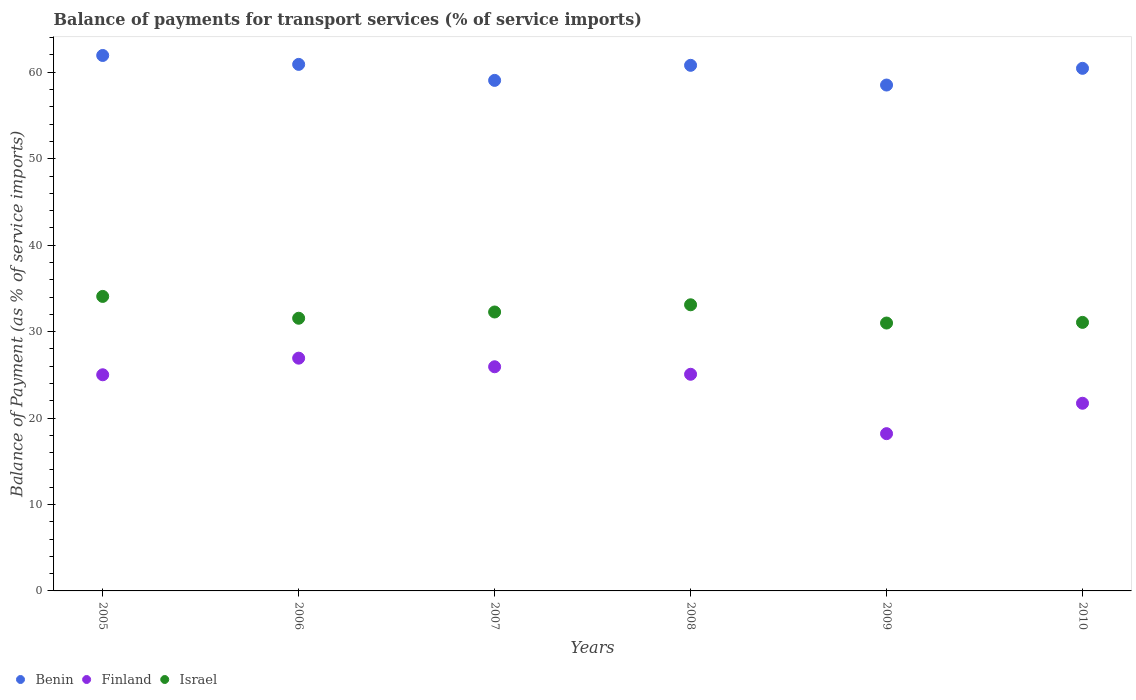How many different coloured dotlines are there?
Give a very brief answer. 3. Is the number of dotlines equal to the number of legend labels?
Your answer should be very brief. Yes. What is the balance of payments for transport services in Israel in 2005?
Provide a succinct answer. 34.07. Across all years, what is the maximum balance of payments for transport services in Benin?
Your answer should be compact. 61.94. Across all years, what is the minimum balance of payments for transport services in Finland?
Make the answer very short. 18.19. In which year was the balance of payments for transport services in Finland maximum?
Your response must be concise. 2006. What is the total balance of payments for transport services in Benin in the graph?
Your answer should be compact. 361.71. What is the difference between the balance of payments for transport services in Benin in 2008 and that in 2009?
Ensure brevity in your answer.  2.28. What is the difference between the balance of payments for transport services in Finland in 2009 and the balance of payments for transport services in Israel in 2007?
Ensure brevity in your answer.  -14.07. What is the average balance of payments for transport services in Benin per year?
Your answer should be compact. 60.28. In the year 2009, what is the difference between the balance of payments for transport services in Benin and balance of payments for transport services in Israel?
Provide a short and direct response. 27.53. What is the ratio of the balance of payments for transport services in Finland in 2005 to that in 2010?
Ensure brevity in your answer.  1.15. Is the balance of payments for transport services in Israel in 2005 less than that in 2010?
Your answer should be compact. No. What is the difference between the highest and the second highest balance of payments for transport services in Finland?
Provide a short and direct response. 1. What is the difference between the highest and the lowest balance of payments for transport services in Finland?
Provide a short and direct response. 8.73. Is the sum of the balance of payments for transport services in Finland in 2007 and 2010 greater than the maximum balance of payments for transport services in Israel across all years?
Ensure brevity in your answer.  Yes. Is it the case that in every year, the sum of the balance of payments for transport services in Israel and balance of payments for transport services in Finland  is greater than the balance of payments for transport services in Benin?
Offer a very short reply. No. Is the balance of payments for transport services in Benin strictly greater than the balance of payments for transport services in Finland over the years?
Your response must be concise. Yes. How many dotlines are there?
Offer a terse response. 3. What is the difference between two consecutive major ticks on the Y-axis?
Provide a short and direct response. 10. Does the graph contain any zero values?
Provide a short and direct response. No. How many legend labels are there?
Keep it short and to the point. 3. What is the title of the graph?
Provide a succinct answer. Balance of payments for transport services (% of service imports). What is the label or title of the Y-axis?
Provide a succinct answer. Balance of Payment (as % of service imports). What is the Balance of Payment (as % of service imports) in Benin in 2005?
Provide a succinct answer. 61.94. What is the Balance of Payment (as % of service imports) of Finland in 2005?
Ensure brevity in your answer.  25. What is the Balance of Payment (as % of service imports) of Israel in 2005?
Give a very brief answer. 34.07. What is the Balance of Payment (as % of service imports) in Benin in 2006?
Keep it short and to the point. 60.91. What is the Balance of Payment (as % of service imports) in Finland in 2006?
Provide a succinct answer. 26.93. What is the Balance of Payment (as % of service imports) of Israel in 2006?
Your answer should be very brief. 31.55. What is the Balance of Payment (as % of service imports) of Benin in 2007?
Provide a short and direct response. 59.06. What is the Balance of Payment (as % of service imports) in Finland in 2007?
Your answer should be compact. 25.93. What is the Balance of Payment (as % of service imports) in Israel in 2007?
Keep it short and to the point. 32.27. What is the Balance of Payment (as % of service imports) in Benin in 2008?
Provide a short and direct response. 60.81. What is the Balance of Payment (as % of service imports) in Finland in 2008?
Offer a terse response. 25.06. What is the Balance of Payment (as % of service imports) of Israel in 2008?
Give a very brief answer. 33.1. What is the Balance of Payment (as % of service imports) in Benin in 2009?
Offer a terse response. 58.52. What is the Balance of Payment (as % of service imports) of Finland in 2009?
Make the answer very short. 18.19. What is the Balance of Payment (as % of service imports) of Israel in 2009?
Your answer should be compact. 30.99. What is the Balance of Payment (as % of service imports) in Benin in 2010?
Provide a short and direct response. 60.46. What is the Balance of Payment (as % of service imports) of Finland in 2010?
Provide a short and direct response. 21.71. What is the Balance of Payment (as % of service imports) of Israel in 2010?
Make the answer very short. 31.07. Across all years, what is the maximum Balance of Payment (as % of service imports) of Benin?
Give a very brief answer. 61.94. Across all years, what is the maximum Balance of Payment (as % of service imports) of Finland?
Your response must be concise. 26.93. Across all years, what is the maximum Balance of Payment (as % of service imports) of Israel?
Give a very brief answer. 34.07. Across all years, what is the minimum Balance of Payment (as % of service imports) in Benin?
Your answer should be very brief. 58.52. Across all years, what is the minimum Balance of Payment (as % of service imports) in Finland?
Give a very brief answer. 18.19. Across all years, what is the minimum Balance of Payment (as % of service imports) in Israel?
Provide a succinct answer. 30.99. What is the total Balance of Payment (as % of service imports) in Benin in the graph?
Ensure brevity in your answer.  361.71. What is the total Balance of Payment (as % of service imports) of Finland in the graph?
Ensure brevity in your answer.  142.83. What is the total Balance of Payment (as % of service imports) in Israel in the graph?
Give a very brief answer. 193.04. What is the difference between the Balance of Payment (as % of service imports) of Benin in 2005 and that in 2006?
Offer a very short reply. 1.03. What is the difference between the Balance of Payment (as % of service imports) in Finland in 2005 and that in 2006?
Offer a terse response. -1.92. What is the difference between the Balance of Payment (as % of service imports) of Israel in 2005 and that in 2006?
Ensure brevity in your answer.  2.53. What is the difference between the Balance of Payment (as % of service imports) in Benin in 2005 and that in 2007?
Give a very brief answer. 2.88. What is the difference between the Balance of Payment (as % of service imports) in Finland in 2005 and that in 2007?
Your response must be concise. -0.93. What is the difference between the Balance of Payment (as % of service imports) in Israel in 2005 and that in 2007?
Your answer should be compact. 1.8. What is the difference between the Balance of Payment (as % of service imports) in Benin in 2005 and that in 2008?
Keep it short and to the point. 1.14. What is the difference between the Balance of Payment (as % of service imports) of Finland in 2005 and that in 2008?
Give a very brief answer. -0.06. What is the difference between the Balance of Payment (as % of service imports) of Israel in 2005 and that in 2008?
Ensure brevity in your answer.  0.97. What is the difference between the Balance of Payment (as % of service imports) in Benin in 2005 and that in 2009?
Your answer should be very brief. 3.42. What is the difference between the Balance of Payment (as % of service imports) in Finland in 2005 and that in 2009?
Provide a short and direct response. 6.81. What is the difference between the Balance of Payment (as % of service imports) in Israel in 2005 and that in 2009?
Keep it short and to the point. 3.08. What is the difference between the Balance of Payment (as % of service imports) of Benin in 2005 and that in 2010?
Provide a succinct answer. 1.49. What is the difference between the Balance of Payment (as % of service imports) in Finland in 2005 and that in 2010?
Your answer should be very brief. 3.29. What is the difference between the Balance of Payment (as % of service imports) in Israel in 2005 and that in 2010?
Give a very brief answer. 3. What is the difference between the Balance of Payment (as % of service imports) of Benin in 2006 and that in 2007?
Offer a very short reply. 1.85. What is the difference between the Balance of Payment (as % of service imports) of Finland in 2006 and that in 2007?
Your response must be concise. 1. What is the difference between the Balance of Payment (as % of service imports) of Israel in 2006 and that in 2007?
Your response must be concise. -0.72. What is the difference between the Balance of Payment (as % of service imports) in Benin in 2006 and that in 2008?
Offer a terse response. 0.11. What is the difference between the Balance of Payment (as % of service imports) in Finland in 2006 and that in 2008?
Make the answer very short. 1.86. What is the difference between the Balance of Payment (as % of service imports) of Israel in 2006 and that in 2008?
Ensure brevity in your answer.  -1.56. What is the difference between the Balance of Payment (as % of service imports) of Benin in 2006 and that in 2009?
Provide a succinct answer. 2.39. What is the difference between the Balance of Payment (as % of service imports) in Finland in 2006 and that in 2009?
Provide a short and direct response. 8.73. What is the difference between the Balance of Payment (as % of service imports) of Israel in 2006 and that in 2009?
Offer a very short reply. 0.55. What is the difference between the Balance of Payment (as % of service imports) of Benin in 2006 and that in 2010?
Ensure brevity in your answer.  0.46. What is the difference between the Balance of Payment (as % of service imports) in Finland in 2006 and that in 2010?
Your response must be concise. 5.22. What is the difference between the Balance of Payment (as % of service imports) in Israel in 2006 and that in 2010?
Your answer should be compact. 0.48. What is the difference between the Balance of Payment (as % of service imports) in Benin in 2007 and that in 2008?
Your answer should be very brief. -1.74. What is the difference between the Balance of Payment (as % of service imports) in Finland in 2007 and that in 2008?
Provide a succinct answer. 0.87. What is the difference between the Balance of Payment (as % of service imports) of Israel in 2007 and that in 2008?
Provide a short and direct response. -0.83. What is the difference between the Balance of Payment (as % of service imports) of Benin in 2007 and that in 2009?
Your response must be concise. 0.54. What is the difference between the Balance of Payment (as % of service imports) of Finland in 2007 and that in 2009?
Offer a terse response. 7.74. What is the difference between the Balance of Payment (as % of service imports) in Israel in 2007 and that in 2009?
Your answer should be compact. 1.28. What is the difference between the Balance of Payment (as % of service imports) of Benin in 2007 and that in 2010?
Keep it short and to the point. -1.39. What is the difference between the Balance of Payment (as % of service imports) in Finland in 2007 and that in 2010?
Make the answer very short. 4.22. What is the difference between the Balance of Payment (as % of service imports) in Israel in 2007 and that in 2010?
Make the answer very short. 1.2. What is the difference between the Balance of Payment (as % of service imports) of Benin in 2008 and that in 2009?
Provide a succinct answer. 2.28. What is the difference between the Balance of Payment (as % of service imports) in Finland in 2008 and that in 2009?
Offer a very short reply. 6.87. What is the difference between the Balance of Payment (as % of service imports) of Israel in 2008 and that in 2009?
Make the answer very short. 2.11. What is the difference between the Balance of Payment (as % of service imports) in Benin in 2008 and that in 2010?
Offer a very short reply. 0.35. What is the difference between the Balance of Payment (as % of service imports) in Finland in 2008 and that in 2010?
Offer a terse response. 3.35. What is the difference between the Balance of Payment (as % of service imports) of Israel in 2008 and that in 2010?
Ensure brevity in your answer.  2.04. What is the difference between the Balance of Payment (as % of service imports) of Benin in 2009 and that in 2010?
Provide a succinct answer. -1.93. What is the difference between the Balance of Payment (as % of service imports) in Finland in 2009 and that in 2010?
Ensure brevity in your answer.  -3.52. What is the difference between the Balance of Payment (as % of service imports) of Israel in 2009 and that in 2010?
Give a very brief answer. -0.08. What is the difference between the Balance of Payment (as % of service imports) in Benin in 2005 and the Balance of Payment (as % of service imports) in Finland in 2006?
Provide a short and direct response. 35.02. What is the difference between the Balance of Payment (as % of service imports) in Benin in 2005 and the Balance of Payment (as % of service imports) in Israel in 2006?
Your answer should be compact. 30.4. What is the difference between the Balance of Payment (as % of service imports) in Finland in 2005 and the Balance of Payment (as % of service imports) in Israel in 2006?
Give a very brief answer. -6.54. What is the difference between the Balance of Payment (as % of service imports) of Benin in 2005 and the Balance of Payment (as % of service imports) of Finland in 2007?
Ensure brevity in your answer.  36.01. What is the difference between the Balance of Payment (as % of service imports) of Benin in 2005 and the Balance of Payment (as % of service imports) of Israel in 2007?
Your answer should be very brief. 29.68. What is the difference between the Balance of Payment (as % of service imports) in Finland in 2005 and the Balance of Payment (as % of service imports) in Israel in 2007?
Provide a succinct answer. -7.26. What is the difference between the Balance of Payment (as % of service imports) of Benin in 2005 and the Balance of Payment (as % of service imports) of Finland in 2008?
Give a very brief answer. 36.88. What is the difference between the Balance of Payment (as % of service imports) of Benin in 2005 and the Balance of Payment (as % of service imports) of Israel in 2008?
Make the answer very short. 28.84. What is the difference between the Balance of Payment (as % of service imports) of Finland in 2005 and the Balance of Payment (as % of service imports) of Israel in 2008?
Offer a terse response. -8.1. What is the difference between the Balance of Payment (as % of service imports) in Benin in 2005 and the Balance of Payment (as % of service imports) in Finland in 2009?
Give a very brief answer. 43.75. What is the difference between the Balance of Payment (as % of service imports) of Benin in 2005 and the Balance of Payment (as % of service imports) of Israel in 2009?
Offer a very short reply. 30.95. What is the difference between the Balance of Payment (as % of service imports) of Finland in 2005 and the Balance of Payment (as % of service imports) of Israel in 2009?
Your response must be concise. -5.99. What is the difference between the Balance of Payment (as % of service imports) in Benin in 2005 and the Balance of Payment (as % of service imports) in Finland in 2010?
Keep it short and to the point. 40.23. What is the difference between the Balance of Payment (as % of service imports) of Benin in 2005 and the Balance of Payment (as % of service imports) of Israel in 2010?
Keep it short and to the point. 30.88. What is the difference between the Balance of Payment (as % of service imports) of Finland in 2005 and the Balance of Payment (as % of service imports) of Israel in 2010?
Your answer should be very brief. -6.06. What is the difference between the Balance of Payment (as % of service imports) of Benin in 2006 and the Balance of Payment (as % of service imports) of Finland in 2007?
Offer a terse response. 34.98. What is the difference between the Balance of Payment (as % of service imports) in Benin in 2006 and the Balance of Payment (as % of service imports) in Israel in 2007?
Ensure brevity in your answer.  28.65. What is the difference between the Balance of Payment (as % of service imports) of Finland in 2006 and the Balance of Payment (as % of service imports) of Israel in 2007?
Offer a terse response. -5.34. What is the difference between the Balance of Payment (as % of service imports) of Benin in 2006 and the Balance of Payment (as % of service imports) of Finland in 2008?
Offer a terse response. 35.85. What is the difference between the Balance of Payment (as % of service imports) in Benin in 2006 and the Balance of Payment (as % of service imports) in Israel in 2008?
Ensure brevity in your answer.  27.81. What is the difference between the Balance of Payment (as % of service imports) of Finland in 2006 and the Balance of Payment (as % of service imports) of Israel in 2008?
Your answer should be compact. -6.17. What is the difference between the Balance of Payment (as % of service imports) in Benin in 2006 and the Balance of Payment (as % of service imports) in Finland in 2009?
Give a very brief answer. 42.72. What is the difference between the Balance of Payment (as % of service imports) of Benin in 2006 and the Balance of Payment (as % of service imports) of Israel in 2009?
Provide a short and direct response. 29.92. What is the difference between the Balance of Payment (as % of service imports) in Finland in 2006 and the Balance of Payment (as % of service imports) in Israel in 2009?
Offer a very short reply. -4.06. What is the difference between the Balance of Payment (as % of service imports) in Benin in 2006 and the Balance of Payment (as % of service imports) in Finland in 2010?
Give a very brief answer. 39.2. What is the difference between the Balance of Payment (as % of service imports) of Benin in 2006 and the Balance of Payment (as % of service imports) of Israel in 2010?
Your response must be concise. 29.85. What is the difference between the Balance of Payment (as % of service imports) of Finland in 2006 and the Balance of Payment (as % of service imports) of Israel in 2010?
Offer a very short reply. -4.14. What is the difference between the Balance of Payment (as % of service imports) of Benin in 2007 and the Balance of Payment (as % of service imports) of Finland in 2008?
Your response must be concise. 34. What is the difference between the Balance of Payment (as % of service imports) of Benin in 2007 and the Balance of Payment (as % of service imports) of Israel in 2008?
Provide a short and direct response. 25.96. What is the difference between the Balance of Payment (as % of service imports) in Finland in 2007 and the Balance of Payment (as % of service imports) in Israel in 2008?
Keep it short and to the point. -7.17. What is the difference between the Balance of Payment (as % of service imports) of Benin in 2007 and the Balance of Payment (as % of service imports) of Finland in 2009?
Ensure brevity in your answer.  40.87. What is the difference between the Balance of Payment (as % of service imports) of Benin in 2007 and the Balance of Payment (as % of service imports) of Israel in 2009?
Ensure brevity in your answer.  28.07. What is the difference between the Balance of Payment (as % of service imports) in Finland in 2007 and the Balance of Payment (as % of service imports) in Israel in 2009?
Provide a succinct answer. -5.06. What is the difference between the Balance of Payment (as % of service imports) in Benin in 2007 and the Balance of Payment (as % of service imports) in Finland in 2010?
Provide a short and direct response. 37.35. What is the difference between the Balance of Payment (as % of service imports) in Benin in 2007 and the Balance of Payment (as % of service imports) in Israel in 2010?
Offer a very short reply. 28. What is the difference between the Balance of Payment (as % of service imports) of Finland in 2007 and the Balance of Payment (as % of service imports) of Israel in 2010?
Your answer should be very brief. -5.13. What is the difference between the Balance of Payment (as % of service imports) of Benin in 2008 and the Balance of Payment (as % of service imports) of Finland in 2009?
Make the answer very short. 42.61. What is the difference between the Balance of Payment (as % of service imports) of Benin in 2008 and the Balance of Payment (as % of service imports) of Israel in 2009?
Give a very brief answer. 29.81. What is the difference between the Balance of Payment (as % of service imports) of Finland in 2008 and the Balance of Payment (as % of service imports) of Israel in 2009?
Ensure brevity in your answer.  -5.93. What is the difference between the Balance of Payment (as % of service imports) in Benin in 2008 and the Balance of Payment (as % of service imports) in Finland in 2010?
Offer a very short reply. 39.09. What is the difference between the Balance of Payment (as % of service imports) of Benin in 2008 and the Balance of Payment (as % of service imports) of Israel in 2010?
Ensure brevity in your answer.  29.74. What is the difference between the Balance of Payment (as % of service imports) of Finland in 2008 and the Balance of Payment (as % of service imports) of Israel in 2010?
Your answer should be compact. -6. What is the difference between the Balance of Payment (as % of service imports) of Benin in 2009 and the Balance of Payment (as % of service imports) of Finland in 2010?
Keep it short and to the point. 36.81. What is the difference between the Balance of Payment (as % of service imports) in Benin in 2009 and the Balance of Payment (as % of service imports) in Israel in 2010?
Ensure brevity in your answer.  27.46. What is the difference between the Balance of Payment (as % of service imports) of Finland in 2009 and the Balance of Payment (as % of service imports) of Israel in 2010?
Offer a terse response. -12.87. What is the average Balance of Payment (as % of service imports) of Benin per year?
Your answer should be compact. 60.28. What is the average Balance of Payment (as % of service imports) in Finland per year?
Provide a succinct answer. 23.81. What is the average Balance of Payment (as % of service imports) of Israel per year?
Provide a succinct answer. 32.17. In the year 2005, what is the difference between the Balance of Payment (as % of service imports) of Benin and Balance of Payment (as % of service imports) of Finland?
Keep it short and to the point. 36.94. In the year 2005, what is the difference between the Balance of Payment (as % of service imports) of Benin and Balance of Payment (as % of service imports) of Israel?
Your answer should be compact. 27.87. In the year 2005, what is the difference between the Balance of Payment (as % of service imports) of Finland and Balance of Payment (as % of service imports) of Israel?
Make the answer very short. -9.07. In the year 2006, what is the difference between the Balance of Payment (as % of service imports) of Benin and Balance of Payment (as % of service imports) of Finland?
Your answer should be very brief. 33.99. In the year 2006, what is the difference between the Balance of Payment (as % of service imports) in Benin and Balance of Payment (as % of service imports) in Israel?
Give a very brief answer. 29.37. In the year 2006, what is the difference between the Balance of Payment (as % of service imports) of Finland and Balance of Payment (as % of service imports) of Israel?
Provide a succinct answer. -4.62. In the year 2007, what is the difference between the Balance of Payment (as % of service imports) of Benin and Balance of Payment (as % of service imports) of Finland?
Keep it short and to the point. 33.13. In the year 2007, what is the difference between the Balance of Payment (as % of service imports) in Benin and Balance of Payment (as % of service imports) in Israel?
Give a very brief answer. 26.8. In the year 2007, what is the difference between the Balance of Payment (as % of service imports) in Finland and Balance of Payment (as % of service imports) in Israel?
Ensure brevity in your answer.  -6.34. In the year 2008, what is the difference between the Balance of Payment (as % of service imports) of Benin and Balance of Payment (as % of service imports) of Finland?
Give a very brief answer. 35.74. In the year 2008, what is the difference between the Balance of Payment (as % of service imports) of Benin and Balance of Payment (as % of service imports) of Israel?
Keep it short and to the point. 27.7. In the year 2008, what is the difference between the Balance of Payment (as % of service imports) in Finland and Balance of Payment (as % of service imports) in Israel?
Provide a short and direct response. -8.04. In the year 2009, what is the difference between the Balance of Payment (as % of service imports) in Benin and Balance of Payment (as % of service imports) in Finland?
Make the answer very short. 40.33. In the year 2009, what is the difference between the Balance of Payment (as % of service imports) in Benin and Balance of Payment (as % of service imports) in Israel?
Provide a short and direct response. 27.53. In the year 2009, what is the difference between the Balance of Payment (as % of service imports) in Finland and Balance of Payment (as % of service imports) in Israel?
Keep it short and to the point. -12.8. In the year 2010, what is the difference between the Balance of Payment (as % of service imports) of Benin and Balance of Payment (as % of service imports) of Finland?
Provide a succinct answer. 38.75. In the year 2010, what is the difference between the Balance of Payment (as % of service imports) of Benin and Balance of Payment (as % of service imports) of Israel?
Give a very brief answer. 29.39. In the year 2010, what is the difference between the Balance of Payment (as % of service imports) in Finland and Balance of Payment (as % of service imports) in Israel?
Offer a very short reply. -9.36. What is the ratio of the Balance of Payment (as % of service imports) in Benin in 2005 to that in 2006?
Provide a short and direct response. 1.02. What is the ratio of the Balance of Payment (as % of service imports) of Israel in 2005 to that in 2006?
Offer a terse response. 1.08. What is the ratio of the Balance of Payment (as % of service imports) in Benin in 2005 to that in 2007?
Keep it short and to the point. 1.05. What is the ratio of the Balance of Payment (as % of service imports) of Finland in 2005 to that in 2007?
Give a very brief answer. 0.96. What is the ratio of the Balance of Payment (as % of service imports) in Israel in 2005 to that in 2007?
Your answer should be very brief. 1.06. What is the ratio of the Balance of Payment (as % of service imports) in Benin in 2005 to that in 2008?
Make the answer very short. 1.02. What is the ratio of the Balance of Payment (as % of service imports) of Israel in 2005 to that in 2008?
Offer a terse response. 1.03. What is the ratio of the Balance of Payment (as % of service imports) in Benin in 2005 to that in 2009?
Make the answer very short. 1.06. What is the ratio of the Balance of Payment (as % of service imports) in Finland in 2005 to that in 2009?
Your answer should be very brief. 1.37. What is the ratio of the Balance of Payment (as % of service imports) of Israel in 2005 to that in 2009?
Offer a very short reply. 1.1. What is the ratio of the Balance of Payment (as % of service imports) of Benin in 2005 to that in 2010?
Your response must be concise. 1.02. What is the ratio of the Balance of Payment (as % of service imports) of Finland in 2005 to that in 2010?
Your answer should be very brief. 1.15. What is the ratio of the Balance of Payment (as % of service imports) in Israel in 2005 to that in 2010?
Offer a very short reply. 1.1. What is the ratio of the Balance of Payment (as % of service imports) of Benin in 2006 to that in 2007?
Offer a very short reply. 1.03. What is the ratio of the Balance of Payment (as % of service imports) of Finland in 2006 to that in 2007?
Keep it short and to the point. 1.04. What is the ratio of the Balance of Payment (as % of service imports) in Israel in 2006 to that in 2007?
Provide a succinct answer. 0.98. What is the ratio of the Balance of Payment (as % of service imports) of Finland in 2006 to that in 2008?
Make the answer very short. 1.07. What is the ratio of the Balance of Payment (as % of service imports) in Israel in 2006 to that in 2008?
Keep it short and to the point. 0.95. What is the ratio of the Balance of Payment (as % of service imports) in Benin in 2006 to that in 2009?
Provide a short and direct response. 1.04. What is the ratio of the Balance of Payment (as % of service imports) of Finland in 2006 to that in 2009?
Provide a succinct answer. 1.48. What is the ratio of the Balance of Payment (as % of service imports) of Israel in 2006 to that in 2009?
Offer a terse response. 1.02. What is the ratio of the Balance of Payment (as % of service imports) of Benin in 2006 to that in 2010?
Provide a succinct answer. 1.01. What is the ratio of the Balance of Payment (as % of service imports) of Finland in 2006 to that in 2010?
Offer a terse response. 1.24. What is the ratio of the Balance of Payment (as % of service imports) in Israel in 2006 to that in 2010?
Provide a succinct answer. 1.02. What is the ratio of the Balance of Payment (as % of service imports) of Benin in 2007 to that in 2008?
Make the answer very short. 0.97. What is the ratio of the Balance of Payment (as % of service imports) in Finland in 2007 to that in 2008?
Offer a very short reply. 1.03. What is the ratio of the Balance of Payment (as % of service imports) in Israel in 2007 to that in 2008?
Provide a short and direct response. 0.97. What is the ratio of the Balance of Payment (as % of service imports) of Benin in 2007 to that in 2009?
Your answer should be very brief. 1.01. What is the ratio of the Balance of Payment (as % of service imports) in Finland in 2007 to that in 2009?
Provide a succinct answer. 1.43. What is the ratio of the Balance of Payment (as % of service imports) in Israel in 2007 to that in 2009?
Provide a short and direct response. 1.04. What is the ratio of the Balance of Payment (as % of service imports) in Benin in 2007 to that in 2010?
Keep it short and to the point. 0.98. What is the ratio of the Balance of Payment (as % of service imports) in Finland in 2007 to that in 2010?
Provide a short and direct response. 1.19. What is the ratio of the Balance of Payment (as % of service imports) of Israel in 2007 to that in 2010?
Ensure brevity in your answer.  1.04. What is the ratio of the Balance of Payment (as % of service imports) in Benin in 2008 to that in 2009?
Keep it short and to the point. 1.04. What is the ratio of the Balance of Payment (as % of service imports) of Finland in 2008 to that in 2009?
Provide a succinct answer. 1.38. What is the ratio of the Balance of Payment (as % of service imports) in Israel in 2008 to that in 2009?
Ensure brevity in your answer.  1.07. What is the ratio of the Balance of Payment (as % of service imports) in Finland in 2008 to that in 2010?
Give a very brief answer. 1.15. What is the ratio of the Balance of Payment (as % of service imports) in Israel in 2008 to that in 2010?
Your response must be concise. 1.07. What is the ratio of the Balance of Payment (as % of service imports) in Finland in 2009 to that in 2010?
Provide a succinct answer. 0.84. What is the ratio of the Balance of Payment (as % of service imports) in Israel in 2009 to that in 2010?
Make the answer very short. 1. What is the difference between the highest and the second highest Balance of Payment (as % of service imports) of Benin?
Your answer should be compact. 1.03. What is the difference between the highest and the second highest Balance of Payment (as % of service imports) of Finland?
Make the answer very short. 1. What is the difference between the highest and the second highest Balance of Payment (as % of service imports) in Israel?
Make the answer very short. 0.97. What is the difference between the highest and the lowest Balance of Payment (as % of service imports) of Benin?
Give a very brief answer. 3.42. What is the difference between the highest and the lowest Balance of Payment (as % of service imports) of Finland?
Provide a succinct answer. 8.73. What is the difference between the highest and the lowest Balance of Payment (as % of service imports) in Israel?
Ensure brevity in your answer.  3.08. 